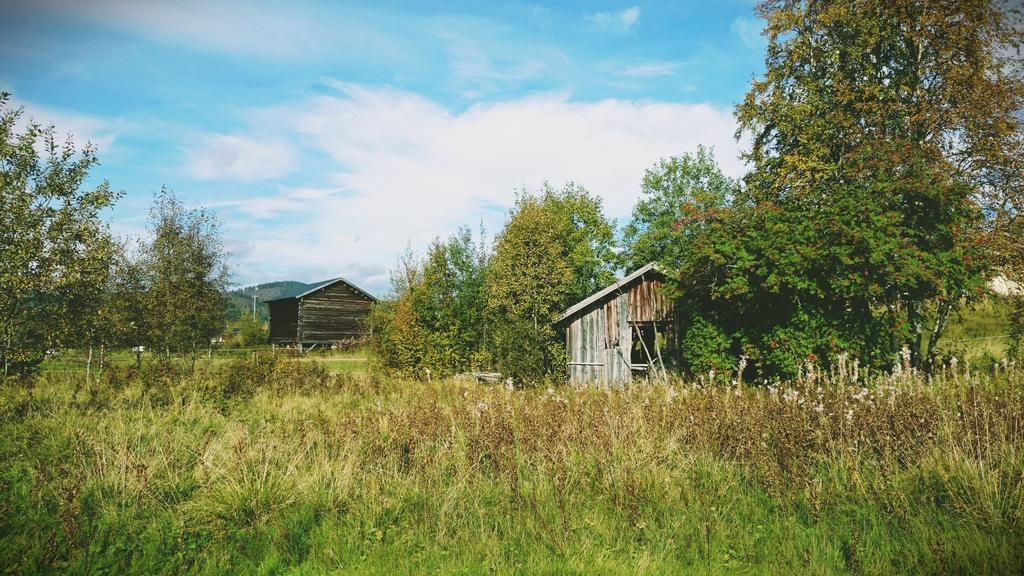What type of vegetation is at the bottom of the image? There is grass at the bottom of the image. What structures are located in the middle of the image? There are wooden houses and trees in the middle of the image. What is visible at the top of the image? The sky is visible at the top of the image. What is the condition of the sky in the image? The sky appears to be cloudy in the image. What type of jam is being served at the feast in the image? There is no feast or jam present in the image; it features grass, wooden houses, trees, and a cloudy sky. What role does the war play in the image? There is no war or any reference to conflict in the image. 